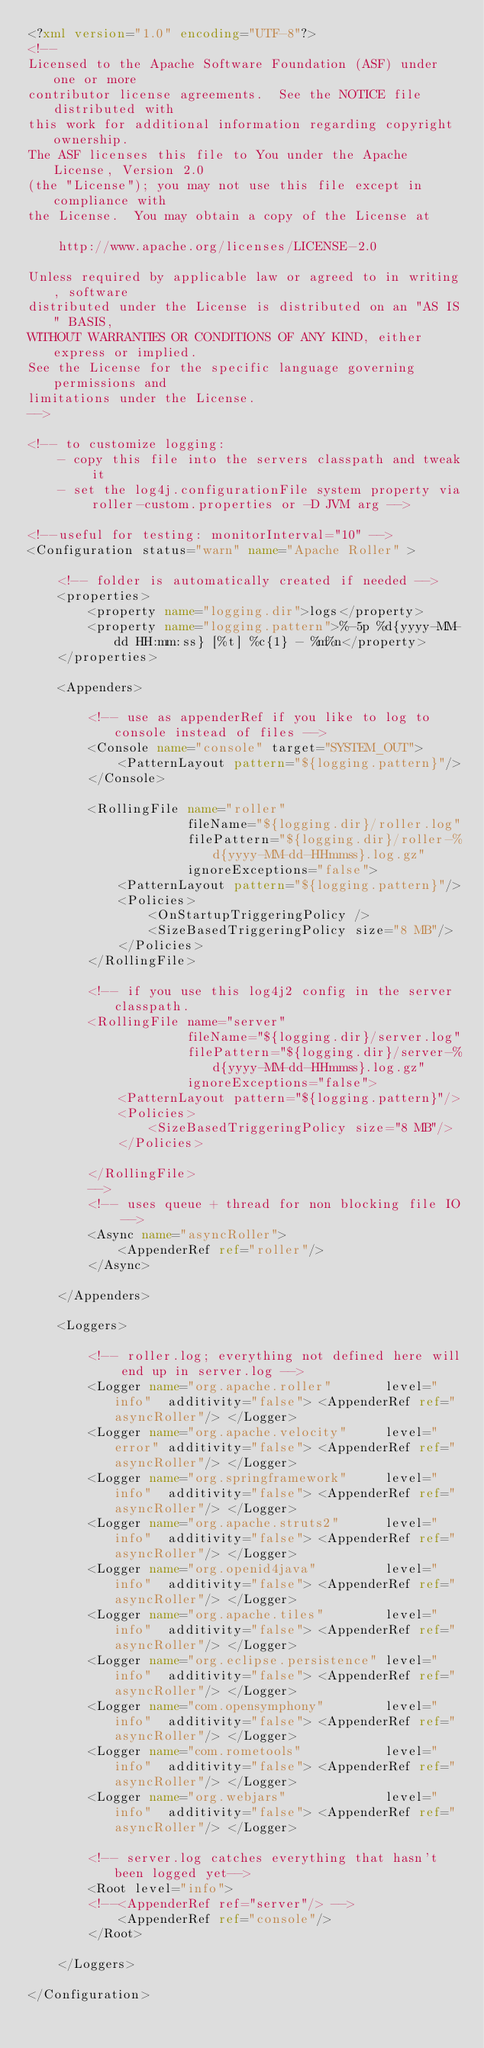Convert code to text. <code><loc_0><loc_0><loc_500><loc_500><_XML_><?xml version="1.0" encoding="UTF-8"?>
<!--
Licensed to the Apache Software Foundation (ASF) under one or more
contributor license agreements.  See the NOTICE file distributed with
this work for additional information regarding copyright ownership.
The ASF licenses this file to You under the Apache License, Version 2.0
(the "License"); you may not use this file except in compliance with
the License.  You may obtain a copy of the License at

    http://www.apache.org/licenses/LICENSE-2.0

Unless required by applicable law or agreed to in writing, software
distributed under the License is distributed on an "AS IS" BASIS,
WITHOUT WARRANTIES OR CONDITIONS OF ANY KIND, either express or implied.
See the License for the specific language governing permissions and
limitations under the License.
-->

<!-- to customize logging:
    - copy this file into the servers classpath and tweak it
    - set the log4j.configurationFile system property via roller-custom.properties or -D JVM arg -->

<!--useful for testing: monitorInterval="10" -->
<Configuration status="warn" name="Apache Roller" >
    
    <!-- folder is automatically created if needed -->
    <properties>
        <property name="logging.dir">logs</property>
        <property name="logging.pattern">%-5p %d{yyyy-MM-dd HH:mm:ss} [%t] %c{1} - %m%n</property>
    </properties>

    <Appenders>

        <!-- use as appenderRef if you like to log to console instead of files -->
        <Console name="console" target="SYSTEM_OUT">
            <PatternLayout pattern="${logging.pattern}"/>
        </Console>
        
        <RollingFile name="roller"
                     fileName="${logging.dir}/roller.log" 
                     filePattern="${logging.dir}/roller-%d{yyyy-MM-dd-HHmmss}.log.gz"
                     ignoreExceptions="false">
            <PatternLayout pattern="${logging.pattern}"/>
            <Policies>
                <OnStartupTriggeringPolicy />
                <SizeBasedTriggeringPolicy size="8 MB"/>
            </Policies>
        </RollingFile>

        <!-- if you use this log4j2 config in the server classpath.
        <RollingFile name="server"
                     fileName="${logging.dir}/server.log" 
                     filePattern="${logging.dir}/server-%d{yyyy-MM-dd-HHmmss}.log.gz"
                     ignoreExceptions="false">
            <PatternLayout pattern="${logging.pattern}"/>
            <Policies>
                <SizeBasedTriggeringPolicy size="8 MB"/>
            </Policies>
            
        </RollingFile>
        -->
        <!-- uses queue + thread for non blocking file IO -->
        <Async name="asyncRoller">
            <AppenderRef ref="roller"/>
        </Async>
        
    </Appenders>

    <Loggers>
        
        <!-- roller.log; everything not defined here will end up in server.log -->
        <Logger name="org.apache.roller"       level="info"  additivity="false"> <AppenderRef ref="asyncRoller"/> </Logger>
        <Logger name="org.apache.velocity"     level="error" additivity="false"> <AppenderRef ref="asyncRoller"/> </Logger>
        <Logger name="org.springframework"     level="info"  additivity="false"> <AppenderRef ref="asyncRoller"/> </Logger>
        <Logger name="org.apache.struts2"      level="info"  additivity="false"> <AppenderRef ref="asyncRoller"/> </Logger>
        <Logger name="org.openid4java"         level="info"  additivity="false"> <AppenderRef ref="asyncRoller"/> </Logger>
        <Logger name="org.apache.tiles"        level="info"  additivity="false"> <AppenderRef ref="asyncRoller"/> </Logger>
        <Logger name="org.eclipse.persistence" level="info"  additivity="false"> <AppenderRef ref="asyncRoller"/> </Logger>
        <Logger name="com.opensymphony"        level="info"  additivity="false"> <AppenderRef ref="asyncRoller"/> </Logger>
        <Logger name="com.rometools"           level="info"  additivity="false"> <AppenderRef ref="asyncRoller"/> </Logger>
        <Logger name="org.webjars"             level="info"  additivity="false"> <AppenderRef ref="asyncRoller"/> </Logger>
        
        <!-- server.log catches everything that hasn't been logged yet-->
        <Root level="info">
        <!--<AppenderRef ref="server"/> -->
            <AppenderRef ref="console"/>
        </Root>
        
    </Loggers>

</Configuration></code> 